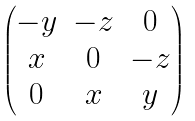<formula> <loc_0><loc_0><loc_500><loc_500>\begin{pmatrix} { - y } & { - z } & 0 \\ x & 0 & { - z } \\ 0 & x & y \end{pmatrix}</formula> 